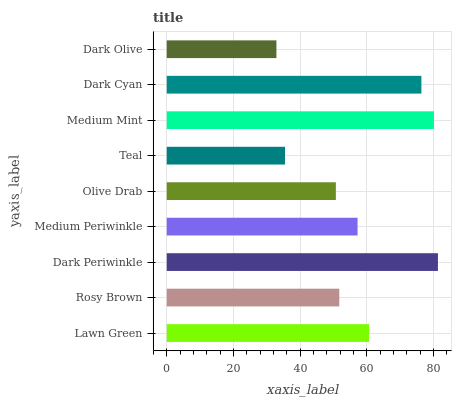Is Dark Olive the minimum?
Answer yes or no. Yes. Is Dark Periwinkle the maximum?
Answer yes or no. Yes. Is Rosy Brown the minimum?
Answer yes or no. No. Is Rosy Brown the maximum?
Answer yes or no. No. Is Lawn Green greater than Rosy Brown?
Answer yes or no. Yes. Is Rosy Brown less than Lawn Green?
Answer yes or no. Yes. Is Rosy Brown greater than Lawn Green?
Answer yes or no. No. Is Lawn Green less than Rosy Brown?
Answer yes or no. No. Is Medium Periwinkle the high median?
Answer yes or no. Yes. Is Medium Periwinkle the low median?
Answer yes or no. Yes. Is Dark Periwinkle the high median?
Answer yes or no. No. Is Medium Mint the low median?
Answer yes or no. No. 